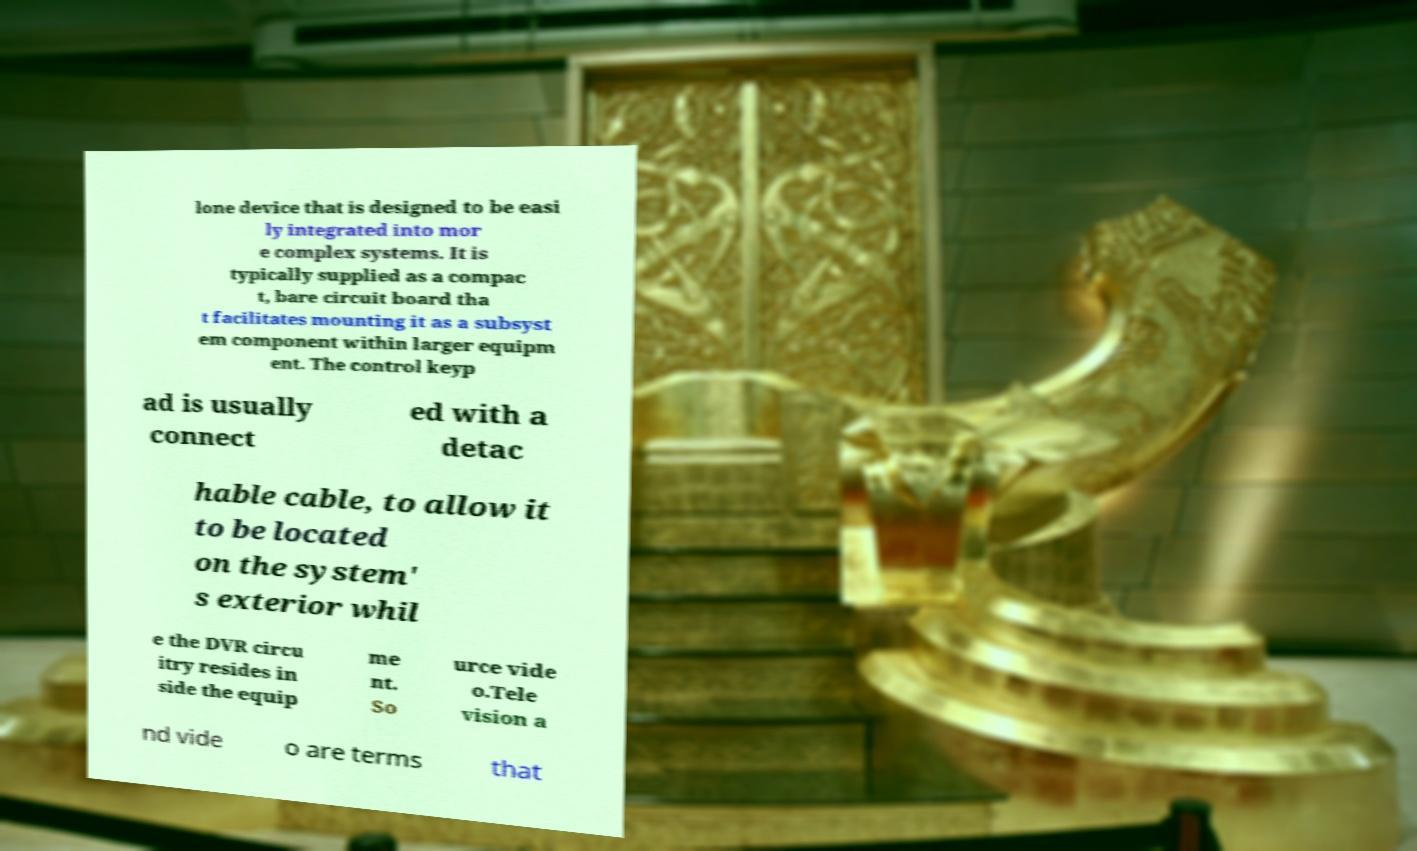Please identify and transcribe the text found in this image. lone device that is designed to be easi ly integrated into mor e complex systems. It is typically supplied as a compac t, bare circuit board tha t facilitates mounting it as a subsyst em component within larger equipm ent. The control keyp ad is usually connect ed with a detac hable cable, to allow it to be located on the system' s exterior whil e the DVR circu itry resides in side the equip me nt. So urce vide o.Tele vision a nd vide o are terms that 